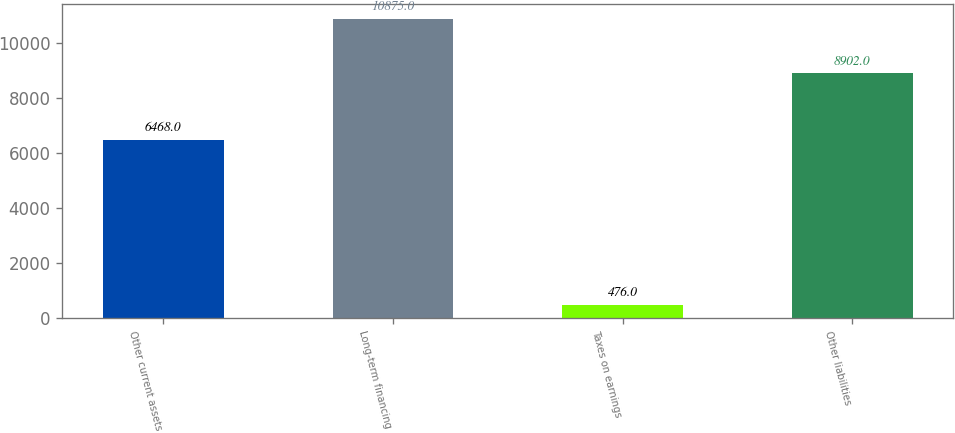Convert chart to OTSL. <chart><loc_0><loc_0><loc_500><loc_500><bar_chart><fcel>Other current assets<fcel>Long-term financing<fcel>Taxes on earnings<fcel>Other liabilities<nl><fcel>6468<fcel>10875<fcel>476<fcel>8902<nl></chart> 